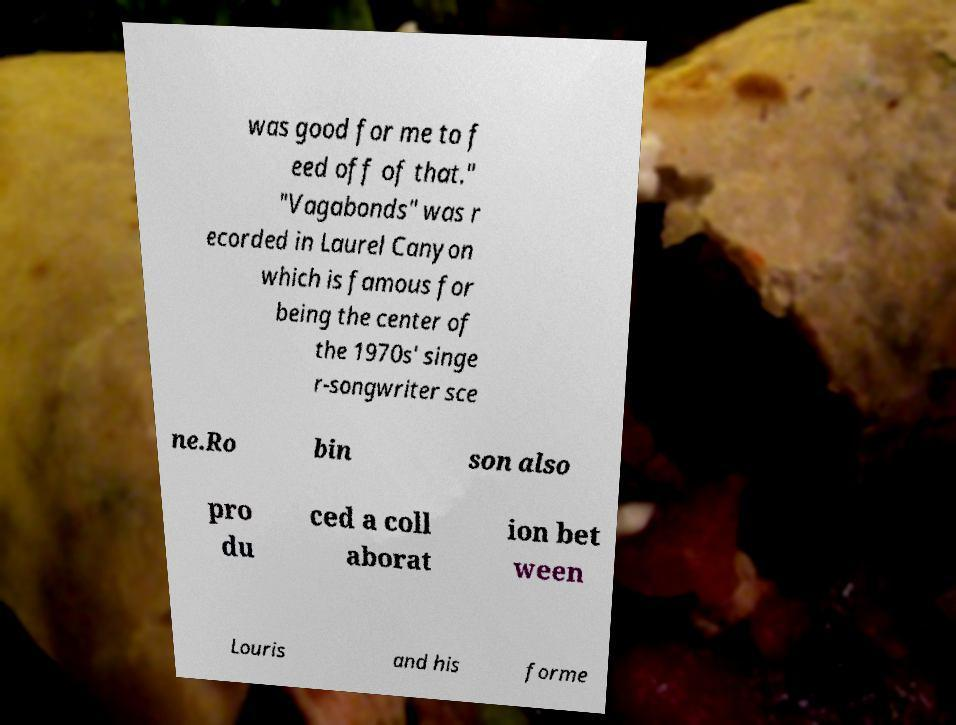What messages or text are displayed in this image? I need them in a readable, typed format. was good for me to f eed off of that." "Vagabonds" was r ecorded in Laurel Canyon which is famous for being the center of the 1970s' singe r-songwriter sce ne.Ro bin son also pro du ced a coll aborat ion bet ween Louris and his forme 